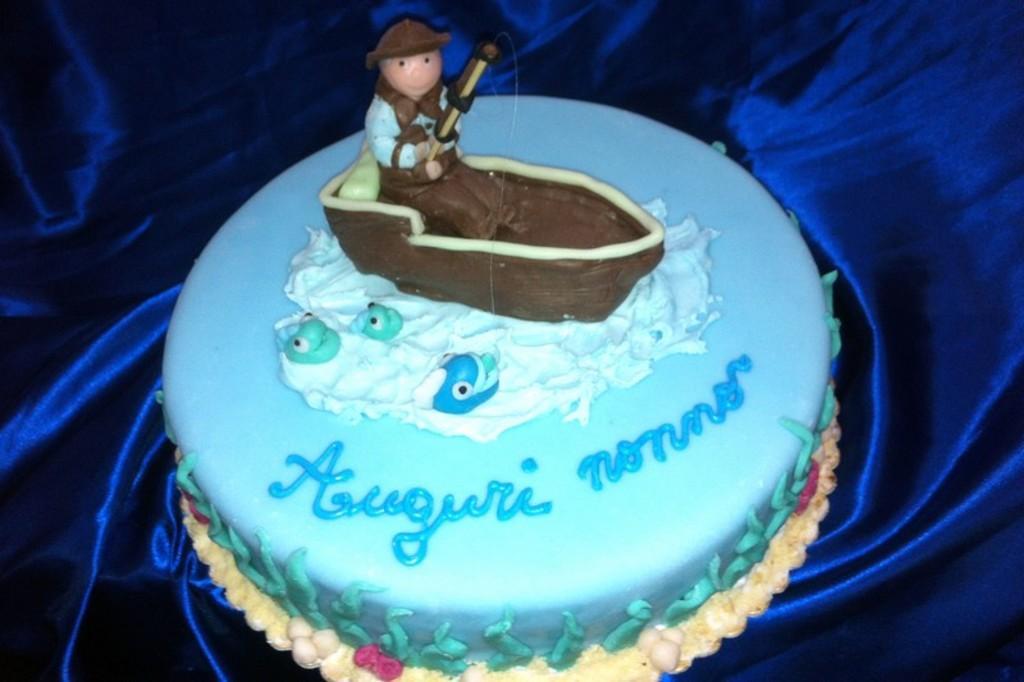Please provide a concise description of this image. In this image we can see a cake which is on the blue color cloth. On the cake we can see something is written on it. 